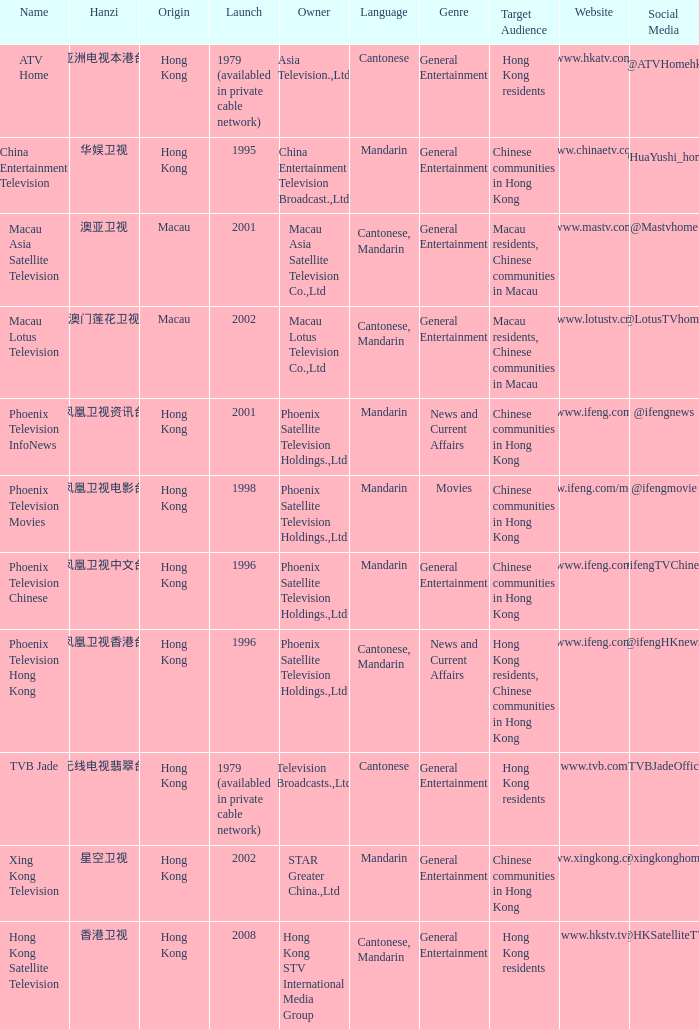What is the Hanzi of Phoenix Television Chinese that launched in 1996? 凤凰卫视中文台. 